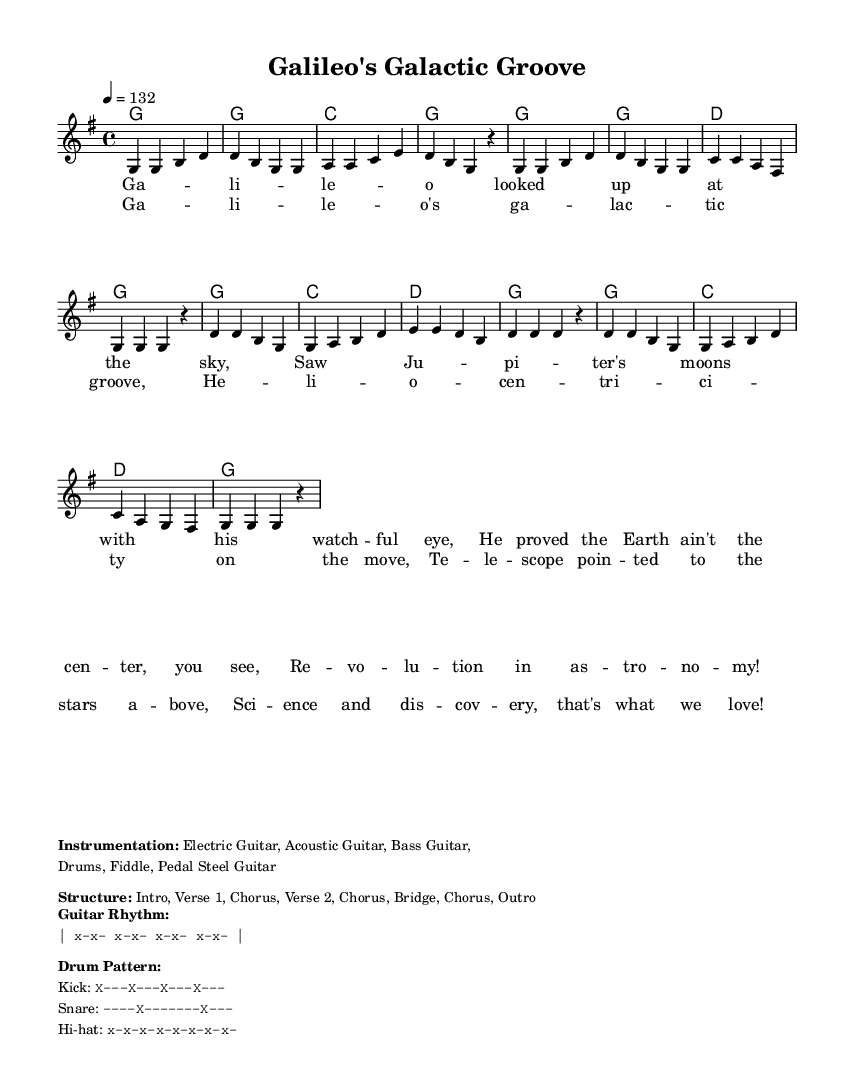What is the key signature of this music? The key signature shown in the music is G major, as indicated by the one sharp (F#) in the key signature area.
Answer: G major What is the time signature of this piece? The time signature displayed in the music specifies a 4/4 time signature, which indicates that there are four beats in each measure.
Answer: 4/4 What is the tempo marking for the piece? The tempo marking indicates a speed of 132 beats per minute, denoted as "4 = 132," which tells musicians how fast to play.
Answer: 132 How many verses are in the structure of this song? The structure described includes two verses, as indicated by the structure outlined in the markup section.
Answer: Two What instrument plays the introduction in this piece? The instrumentation suggests that Electric Guitar plays the introduction as part of the sound setup for the piece.
Answer: Electric Guitar What is the primary theme of the lyrics? The lyrics focus on Galileo's contributions to science, specifically his observations of Jupiter's moons and the heliocentric theory.
Answer: Galileo's scientific contributions 